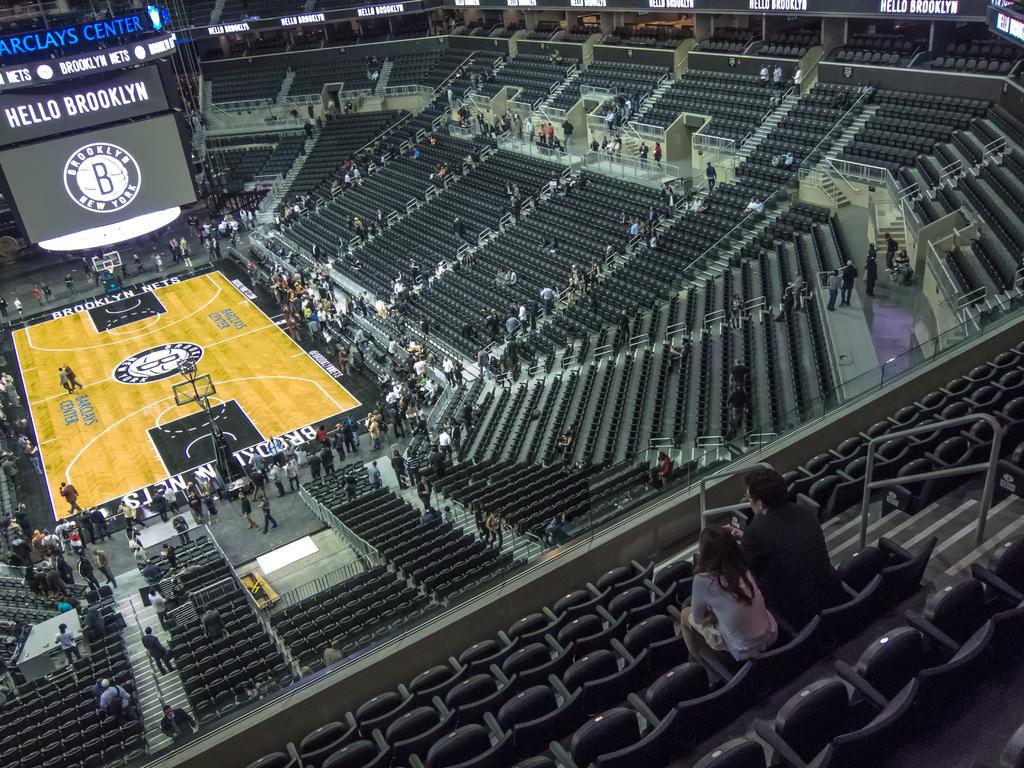Which city is this stadium in?
Keep it short and to the point. Brooklyn. What is the name of this stadium?
Ensure brevity in your answer.  Barclays center. 